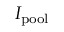<formula> <loc_0><loc_0><loc_500><loc_500>I _ { p o o l }</formula> 